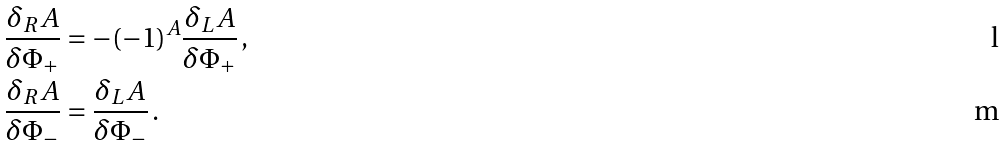<formula> <loc_0><loc_0><loc_500><loc_500>\frac { \delta _ { R } A } { \delta \Phi _ { + } } & = - ( - 1 ) ^ { A } \frac { \delta _ { L } A } { \delta \Phi _ { + } } \, , \\ \frac { \delta _ { R } A } { \delta \Phi _ { - } } & = \frac { \delta _ { L } A } { \delta \Phi _ { - } } \, .</formula> 